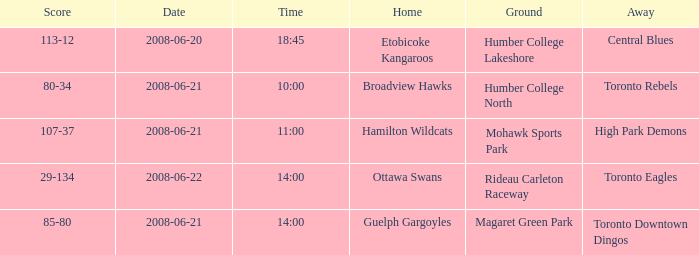What is the Away with a Ground that is humber college lakeshore? Central Blues. 